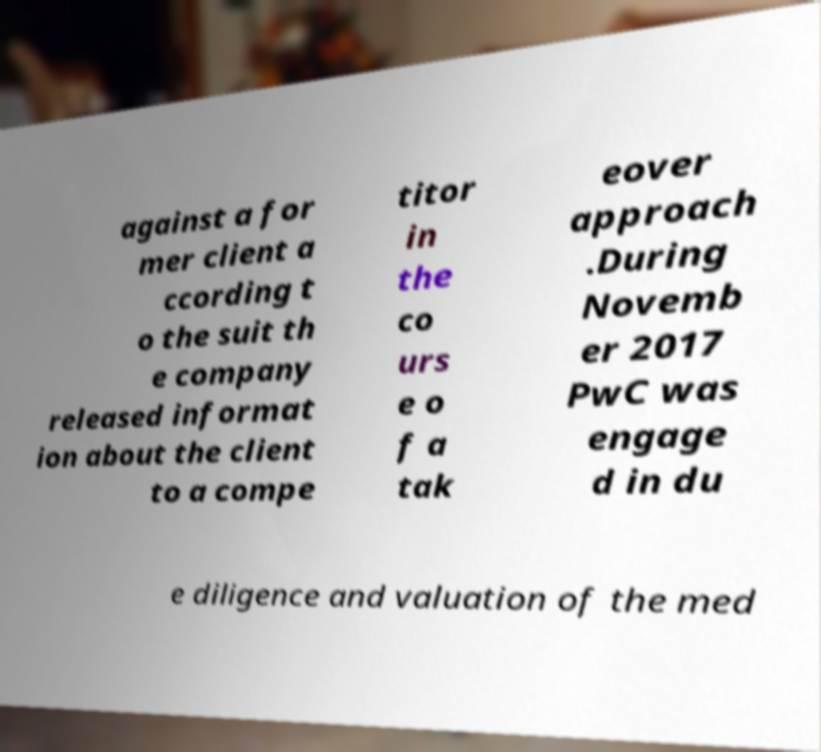I need the written content from this picture converted into text. Can you do that? against a for mer client a ccording t o the suit th e company released informat ion about the client to a compe titor in the co urs e o f a tak eover approach .During Novemb er 2017 PwC was engage d in du e diligence and valuation of the med 